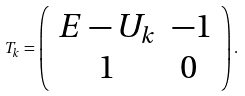Convert formula to latex. <formula><loc_0><loc_0><loc_500><loc_500>T _ { k } = \left ( \begin{array} { c c } E - U _ { k } & - 1 \\ 1 & 0 \ \end{array} \right ) .</formula> 